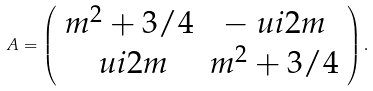<formula> <loc_0><loc_0><loc_500><loc_500>A = \left ( \begin{array} { c c } m ^ { 2 } + 3 / 4 & - \ u i 2 m \\ \ u i 2 m & m ^ { 2 } + 3 / 4 \end{array} \right ) .</formula> 